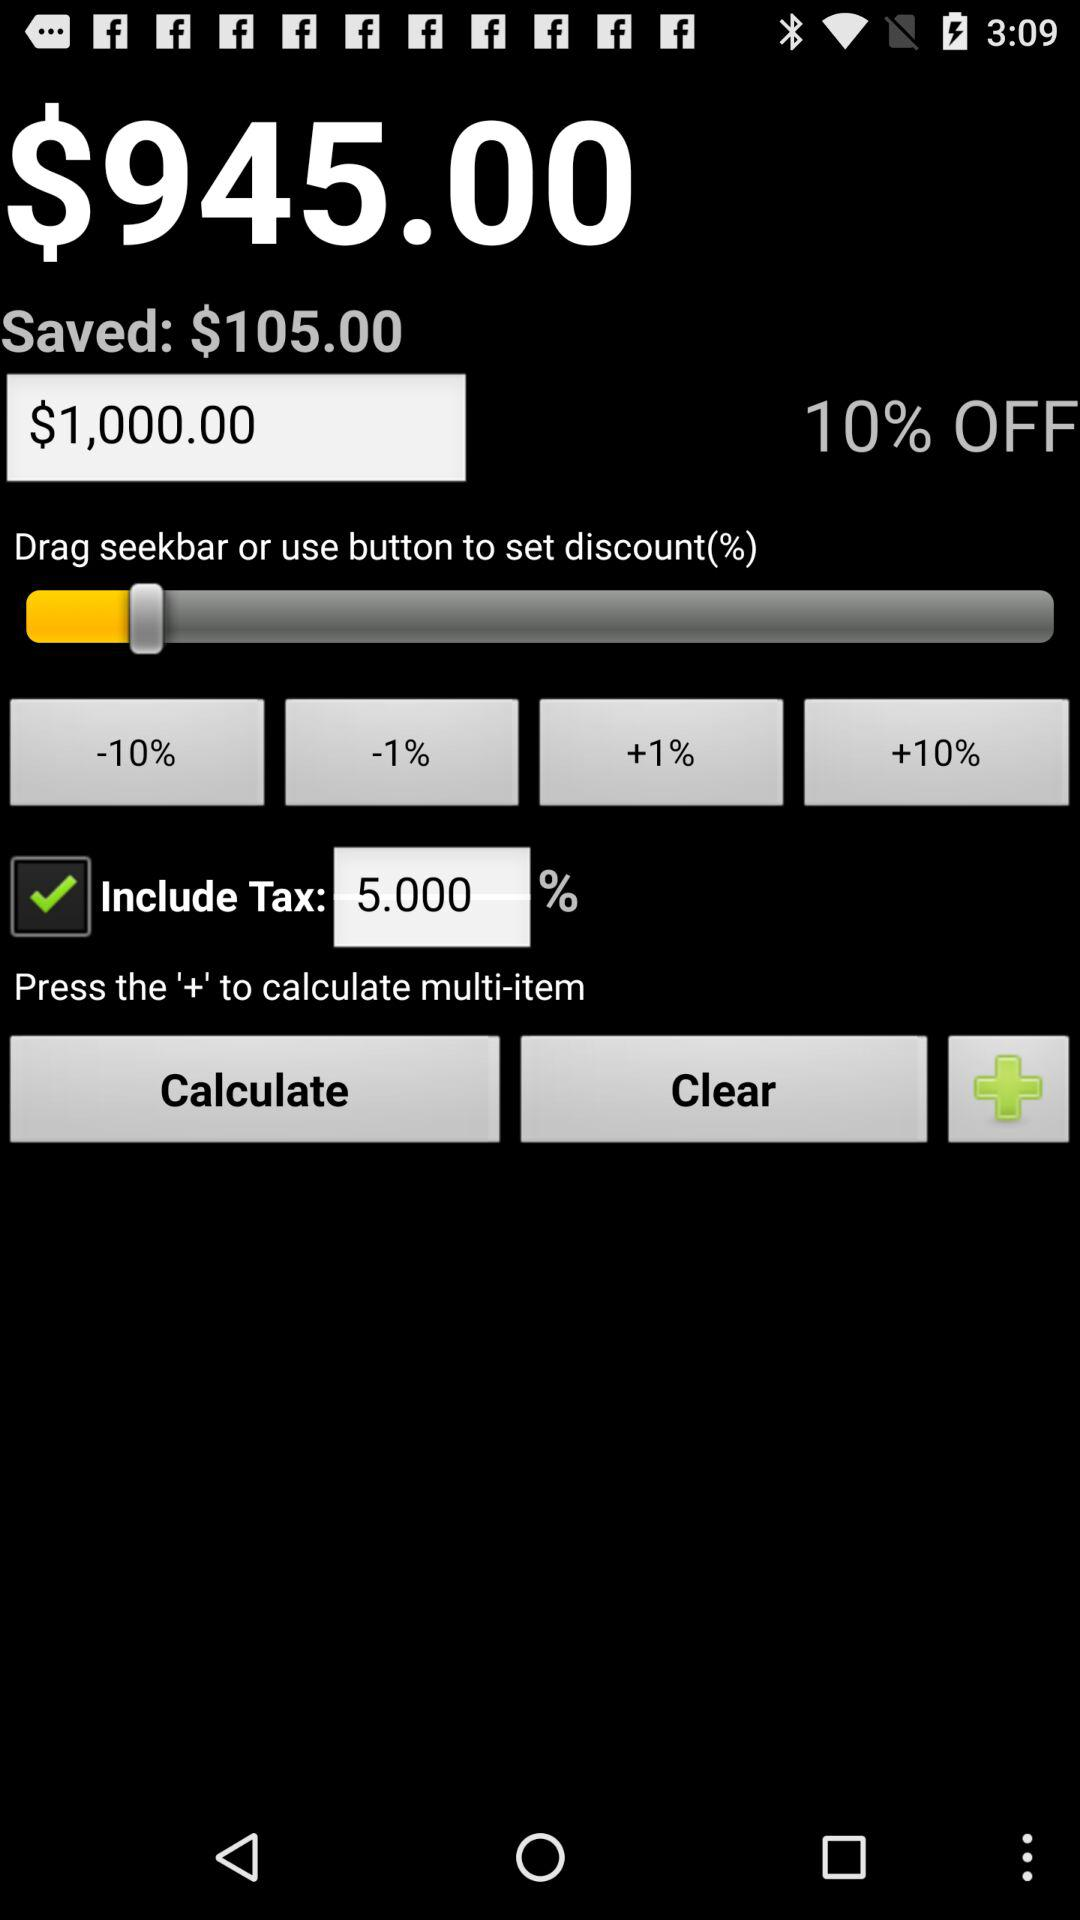What is the tax percentage? The tax percentage is 5. 